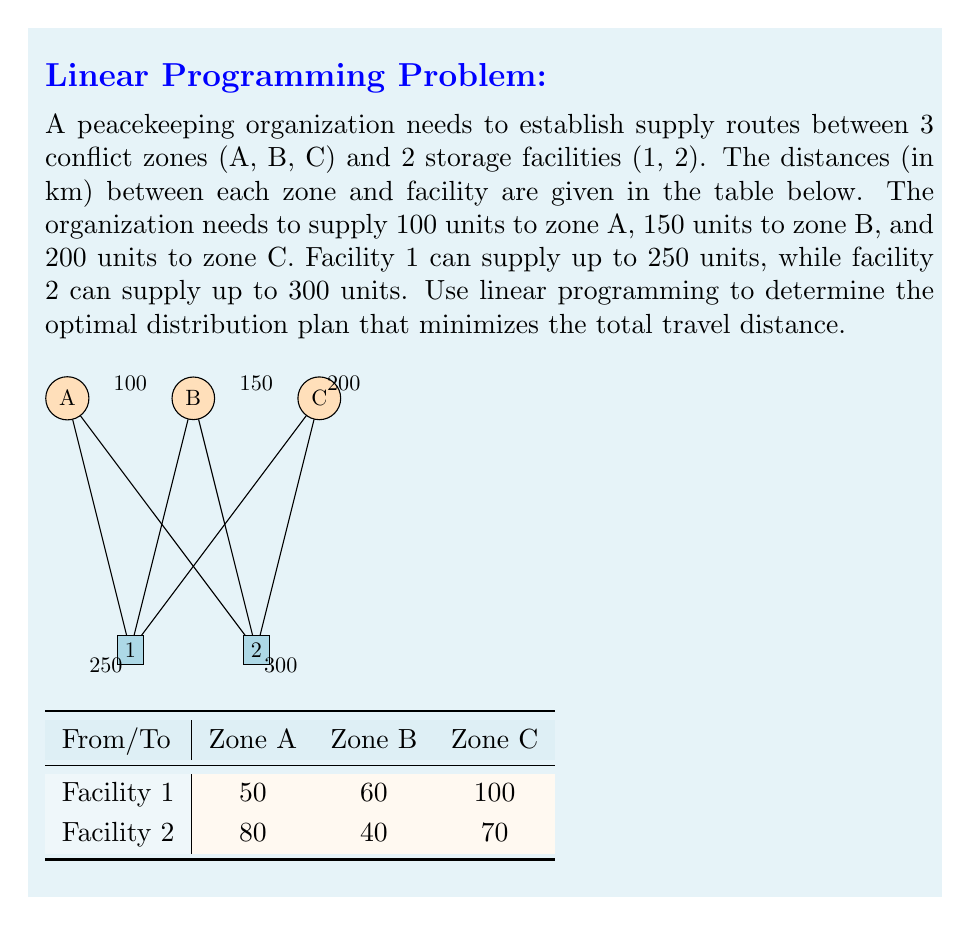Provide a solution to this math problem. To solve this linear programming problem, we'll follow these steps:

1. Define variables:
   Let $x_{ij}$ be the number of units sent from facility $i$ to zone $j$.

2. Set up the objective function:
   Minimize $Z = 50x_{1A} + 60x_{1B} + 100x_{1C} + 80x_{2A} + 40x_{2B} + 70x_{2C}$

3. Define constraints:
   a) Supply constraints:
      Facility 1: $x_{1A} + x_{1B} + x_{1C} \leq 250$
      Facility 2: $x_{2A} + x_{2B} + x_{2C} \leq 300$
   
   b) Demand constraints:
      Zone A: $x_{1A} + x_{2A} = 100$
      Zone B: $x_{1B} + x_{2B} = 150$
      Zone C: $x_{1C} + x_{2C} = 200$
   
   c) Non-negativity constraints:
      $x_{ij} \geq 0$ for all $i$ and $j$

4. Solve the linear programming problem using a solver (e.g., simplex method).

5. The optimal solution is:
   $x_{1A} = 100, x_{1B} = 150, x_{1C} = 0, x_{2A} = 0, x_{2B} = 0, x_{2C} = 200$

6. Calculate the minimum total travel distance:
   $Z = 50(100) + 60(150) + 100(0) + 80(0) + 40(0) + 70(200) = 5000 + 9000 + 14000 = 28000$ km
Answer: 28000 km 